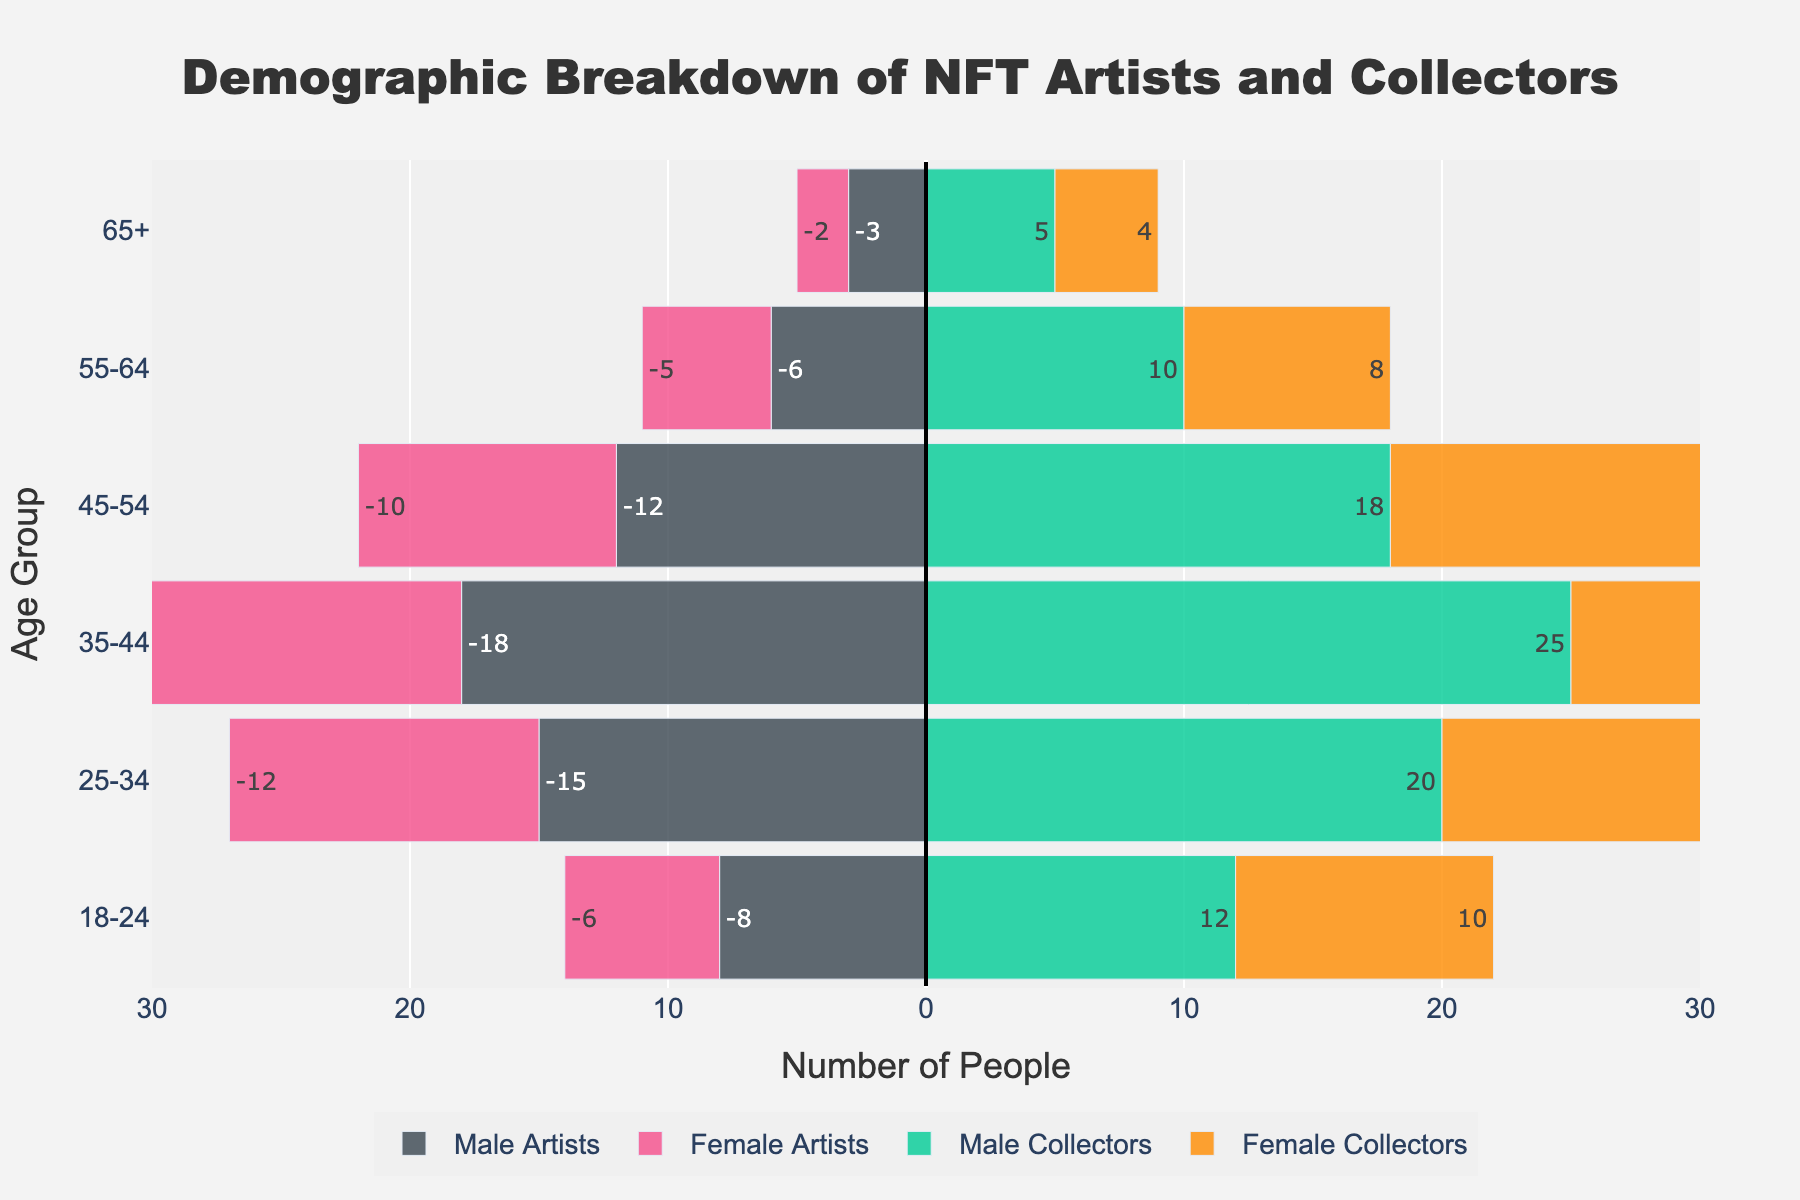What is the title of the figure? The title of the figure is displayed at the top and provides an overview of the data being presented. It helps users understand the subject of the visualization.
Answer: Demographic Breakdown of NFT Artists and Collectors How many age groups are represented in the figure? Count the age groups listed on the y-axis from top to bottom. There are six distinct age groups shown.
Answer: Six Between the ages of 18-24, are there more male artists or male collectors? Compare the length of the bars for male artists and male collectors within the 18-24 age group. The positive bar (collectors) is longer than the negative bar (artists).
Answer: Male collectors Which gender has more artists in the 35-44 age group? Compare the lengths of the bars for male and female artists. The bar for male artists extends further to the left than the bar for female artists, indicating a higher number.
Answer: Male artists Do female collectors outnumber female artists in the 45-54 age group? Check the lengths of the bars for female collectors and female artists in the 45-54 age group. The bar for female collectors extends further to the right than the bar for female artists to the left.
Answer: Yes What is the total number of NFT artists in the 25-34 age group? Add the values of male and female artists in the 25-34 age group. For male artists, it's 15, and for female artists, it's 12, so 15 + 12.
Answer: 27 Among the 55-64 age group, which gender of collectors has the smallest representation? Compare the lengths of the bars for male and female collectors in the 55-64 age group. The bar for female collectors is shorter than the bar for male collectors.
Answer: Female collectors Which age group has the most male collectors? Compare the lengths of all the bars for male collectors across all age groups. The bar for the 35-44 age group extends the furthest to the right.
Answer: 35-44 In the 65+ age group, is there a higher number of female artists or female collectors? Compare the lengths of the bars for female artists and female collectors in the 65+ age group. The bar for female collectors is longer than the bar for female artists.
Answer: Female collectors What is the total number of NFT collectors aged 45-54? Sum the values of male and female collectors in the 45-54 age group. There are 18 male collectors and 15 female collectors, so 18 + 15.
Answer: 33 